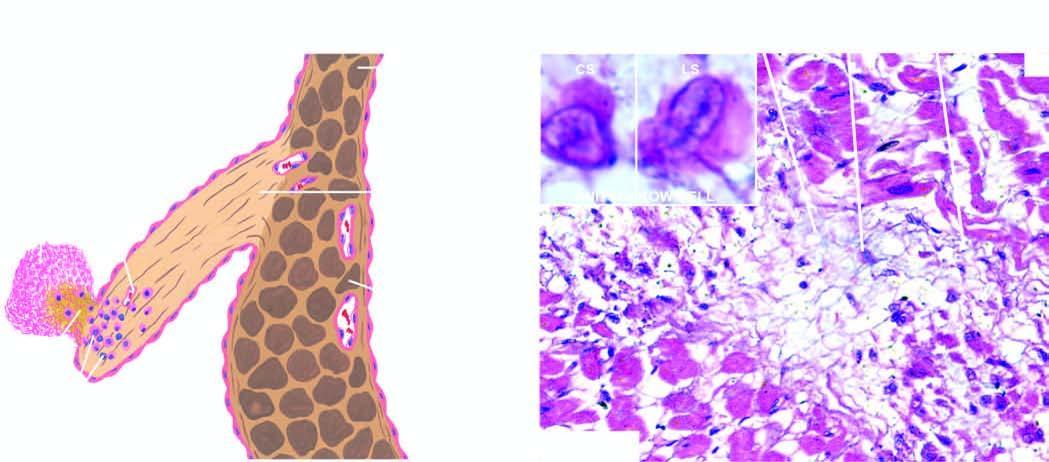does section of the myocardium show healed aschoff nodules in the interstitium having collagen, sparse cellula rity, a multinucleate giant cell and anitschkow cells?
Answer the question using a single word or phrase. Yes 